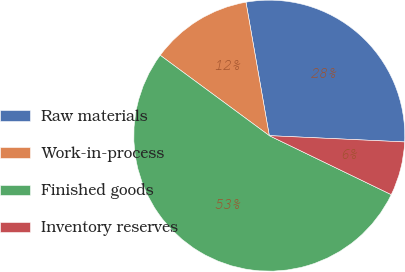Convert chart. <chart><loc_0><loc_0><loc_500><loc_500><pie_chart><fcel>Raw materials<fcel>Work-in-process<fcel>Finished goods<fcel>Inventory reserves<nl><fcel>28.49%<fcel>12.14%<fcel>52.93%<fcel>6.43%<nl></chart> 